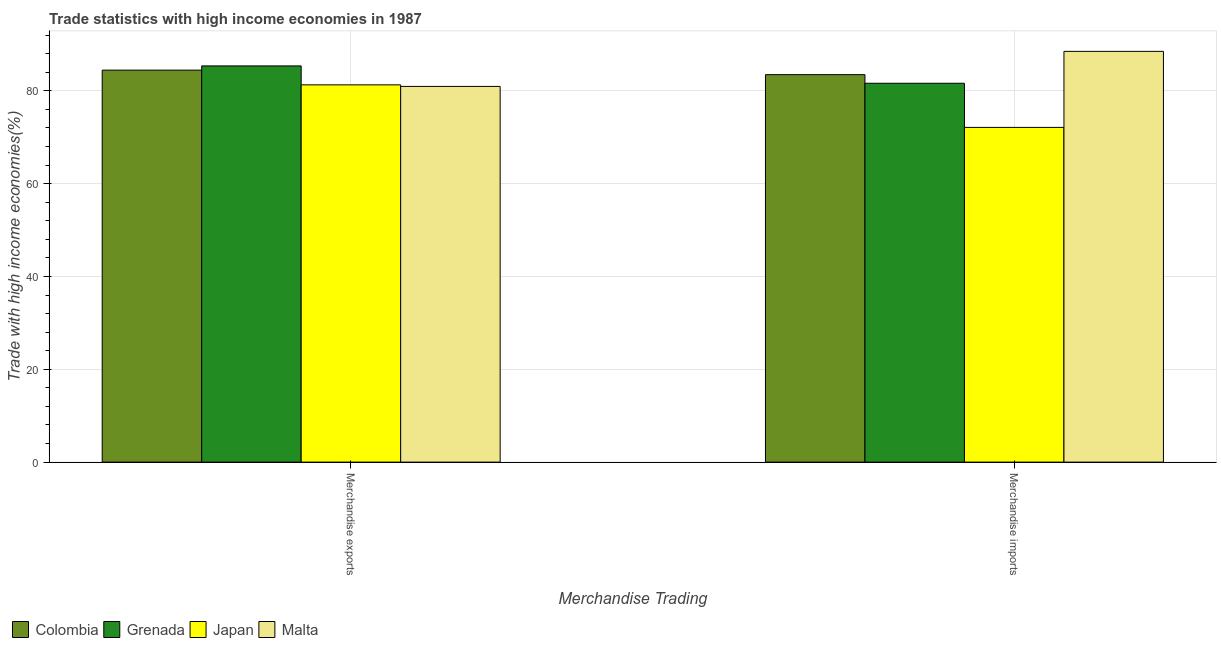How many groups of bars are there?
Keep it short and to the point. 2. Are the number of bars per tick equal to the number of legend labels?
Ensure brevity in your answer.  Yes. Are the number of bars on each tick of the X-axis equal?
Ensure brevity in your answer.  Yes. How many bars are there on the 1st tick from the left?
Offer a terse response. 4. What is the merchandise exports in Grenada?
Offer a terse response. 85.38. Across all countries, what is the maximum merchandise imports?
Your answer should be very brief. 88.51. Across all countries, what is the minimum merchandise exports?
Offer a very short reply. 80.96. In which country was the merchandise exports maximum?
Ensure brevity in your answer.  Grenada. In which country was the merchandise imports minimum?
Your response must be concise. Japan. What is the total merchandise exports in the graph?
Keep it short and to the point. 332.09. What is the difference between the merchandise imports in Colombia and that in Japan?
Provide a short and direct response. 11.37. What is the difference between the merchandise imports in Malta and the merchandise exports in Colombia?
Keep it short and to the point. 4.04. What is the average merchandise imports per country?
Provide a short and direct response. 81.44. What is the difference between the merchandise exports and merchandise imports in Malta?
Provide a succinct answer. -7.55. What is the ratio of the merchandise exports in Malta to that in Grenada?
Your response must be concise. 0.95. What does the 2nd bar from the left in Merchandise exports represents?
Give a very brief answer. Grenada. What does the 3rd bar from the right in Merchandise imports represents?
Give a very brief answer. Grenada. Are all the bars in the graph horizontal?
Offer a very short reply. No. What is the difference between two consecutive major ticks on the Y-axis?
Make the answer very short. 20. Are the values on the major ticks of Y-axis written in scientific E-notation?
Offer a terse response. No. Where does the legend appear in the graph?
Offer a terse response. Bottom left. What is the title of the graph?
Provide a succinct answer. Trade statistics with high income economies in 1987. What is the label or title of the X-axis?
Keep it short and to the point. Merchandise Trading. What is the label or title of the Y-axis?
Offer a terse response. Trade with high income economies(%). What is the Trade with high income economies(%) in Colombia in Merchandise exports?
Keep it short and to the point. 84.47. What is the Trade with high income economies(%) of Grenada in Merchandise exports?
Offer a terse response. 85.38. What is the Trade with high income economies(%) in Japan in Merchandise exports?
Your answer should be very brief. 81.29. What is the Trade with high income economies(%) of Malta in Merchandise exports?
Offer a very short reply. 80.96. What is the Trade with high income economies(%) in Colombia in Merchandise imports?
Keep it short and to the point. 83.49. What is the Trade with high income economies(%) in Grenada in Merchandise imports?
Your answer should be very brief. 81.64. What is the Trade with high income economies(%) in Japan in Merchandise imports?
Your answer should be very brief. 72.13. What is the Trade with high income economies(%) of Malta in Merchandise imports?
Make the answer very short. 88.51. Across all Merchandise Trading, what is the maximum Trade with high income economies(%) in Colombia?
Your answer should be compact. 84.47. Across all Merchandise Trading, what is the maximum Trade with high income economies(%) of Grenada?
Your answer should be compact. 85.38. Across all Merchandise Trading, what is the maximum Trade with high income economies(%) in Japan?
Your answer should be compact. 81.29. Across all Merchandise Trading, what is the maximum Trade with high income economies(%) of Malta?
Provide a short and direct response. 88.51. Across all Merchandise Trading, what is the minimum Trade with high income economies(%) in Colombia?
Keep it short and to the point. 83.49. Across all Merchandise Trading, what is the minimum Trade with high income economies(%) in Grenada?
Offer a very short reply. 81.64. Across all Merchandise Trading, what is the minimum Trade with high income economies(%) in Japan?
Your answer should be compact. 72.13. Across all Merchandise Trading, what is the minimum Trade with high income economies(%) of Malta?
Your response must be concise. 80.96. What is the total Trade with high income economies(%) in Colombia in the graph?
Offer a terse response. 167.96. What is the total Trade with high income economies(%) in Grenada in the graph?
Your answer should be compact. 167.01. What is the total Trade with high income economies(%) in Japan in the graph?
Your answer should be very brief. 153.42. What is the total Trade with high income economies(%) in Malta in the graph?
Your answer should be very brief. 169.47. What is the difference between the Trade with high income economies(%) of Colombia in Merchandise exports and that in Merchandise imports?
Give a very brief answer. 0.97. What is the difference between the Trade with high income economies(%) of Grenada in Merchandise exports and that in Merchandise imports?
Offer a terse response. 3.74. What is the difference between the Trade with high income economies(%) in Japan in Merchandise exports and that in Merchandise imports?
Offer a terse response. 9.17. What is the difference between the Trade with high income economies(%) in Malta in Merchandise exports and that in Merchandise imports?
Your answer should be compact. -7.55. What is the difference between the Trade with high income economies(%) in Colombia in Merchandise exports and the Trade with high income economies(%) in Grenada in Merchandise imports?
Your answer should be compact. 2.83. What is the difference between the Trade with high income economies(%) of Colombia in Merchandise exports and the Trade with high income economies(%) of Japan in Merchandise imports?
Your answer should be compact. 12.34. What is the difference between the Trade with high income economies(%) in Colombia in Merchandise exports and the Trade with high income economies(%) in Malta in Merchandise imports?
Offer a very short reply. -4.04. What is the difference between the Trade with high income economies(%) in Grenada in Merchandise exports and the Trade with high income economies(%) in Japan in Merchandise imports?
Provide a short and direct response. 13.25. What is the difference between the Trade with high income economies(%) in Grenada in Merchandise exports and the Trade with high income economies(%) in Malta in Merchandise imports?
Give a very brief answer. -3.14. What is the difference between the Trade with high income economies(%) of Japan in Merchandise exports and the Trade with high income economies(%) of Malta in Merchandise imports?
Offer a very short reply. -7.22. What is the average Trade with high income economies(%) of Colombia per Merchandise Trading?
Your response must be concise. 83.98. What is the average Trade with high income economies(%) of Grenada per Merchandise Trading?
Provide a short and direct response. 83.51. What is the average Trade with high income economies(%) of Japan per Merchandise Trading?
Provide a short and direct response. 76.71. What is the average Trade with high income economies(%) in Malta per Merchandise Trading?
Offer a very short reply. 84.73. What is the difference between the Trade with high income economies(%) of Colombia and Trade with high income economies(%) of Grenada in Merchandise exports?
Provide a succinct answer. -0.91. What is the difference between the Trade with high income economies(%) in Colombia and Trade with high income economies(%) in Japan in Merchandise exports?
Provide a short and direct response. 3.17. What is the difference between the Trade with high income economies(%) of Colombia and Trade with high income economies(%) of Malta in Merchandise exports?
Your answer should be very brief. 3.51. What is the difference between the Trade with high income economies(%) of Grenada and Trade with high income economies(%) of Japan in Merchandise exports?
Keep it short and to the point. 4.08. What is the difference between the Trade with high income economies(%) of Grenada and Trade with high income economies(%) of Malta in Merchandise exports?
Keep it short and to the point. 4.42. What is the difference between the Trade with high income economies(%) of Japan and Trade with high income economies(%) of Malta in Merchandise exports?
Make the answer very short. 0.33. What is the difference between the Trade with high income economies(%) in Colombia and Trade with high income economies(%) in Grenada in Merchandise imports?
Ensure brevity in your answer.  1.85. What is the difference between the Trade with high income economies(%) of Colombia and Trade with high income economies(%) of Japan in Merchandise imports?
Ensure brevity in your answer.  11.37. What is the difference between the Trade with high income economies(%) of Colombia and Trade with high income economies(%) of Malta in Merchandise imports?
Give a very brief answer. -5.02. What is the difference between the Trade with high income economies(%) of Grenada and Trade with high income economies(%) of Japan in Merchandise imports?
Your answer should be very brief. 9.51. What is the difference between the Trade with high income economies(%) in Grenada and Trade with high income economies(%) in Malta in Merchandise imports?
Offer a terse response. -6.87. What is the difference between the Trade with high income economies(%) in Japan and Trade with high income economies(%) in Malta in Merchandise imports?
Provide a short and direct response. -16.38. What is the ratio of the Trade with high income economies(%) in Colombia in Merchandise exports to that in Merchandise imports?
Your response must be concise. 1.01. What is the ratio of the Trade with high income economies(%) in Grenada in Merchandise exports to that in Merchandise imports?
Provide a succinct answer. 1.05. What is the ratio of the Trade with high income economies(%) of Japan in Merchandise exports to that in Merchandise imports?
Provide a short and direct response. 1.13. What is the ratio of the Trade with high income economies(%) of Malta in Merchandise exports to that in Merchandise imports?
Keep it short and to the point. 0.91. What is the difference between the highest and the second highest Trade with high income economies(%) of Colombia?
Your response must be concise. 0.97. What is the difference between the highest and the second highest Trade with high income economies(%) of Grenada?
Your answer should be very brief. 3.74. What is the difference between the highest and the second highest Trade with high income economies(%) of Japan?
Give a very brief answer. 9.17. What is the difference between the highest and the second highest Trade with high income economies(%) in Malta?
Provide a short and direct response. 7.55. What is the difference between the highest and the lowest Trade with high income economies(%) of Colombia?
Your response must be concise. 0.97. What is the difference between the highest and the lowest Trade with high income economies(%) in Grenada?
Your answer should be very brief. 3.74. What is the difference between the highest and the lowest Trade with high income economies(%) of Japan?
Your answer should be compact. 9.17. What is the difference between the highest and the lowest Trade with high income economies(%) in Malta?
Your response must be concise. 7.55. 